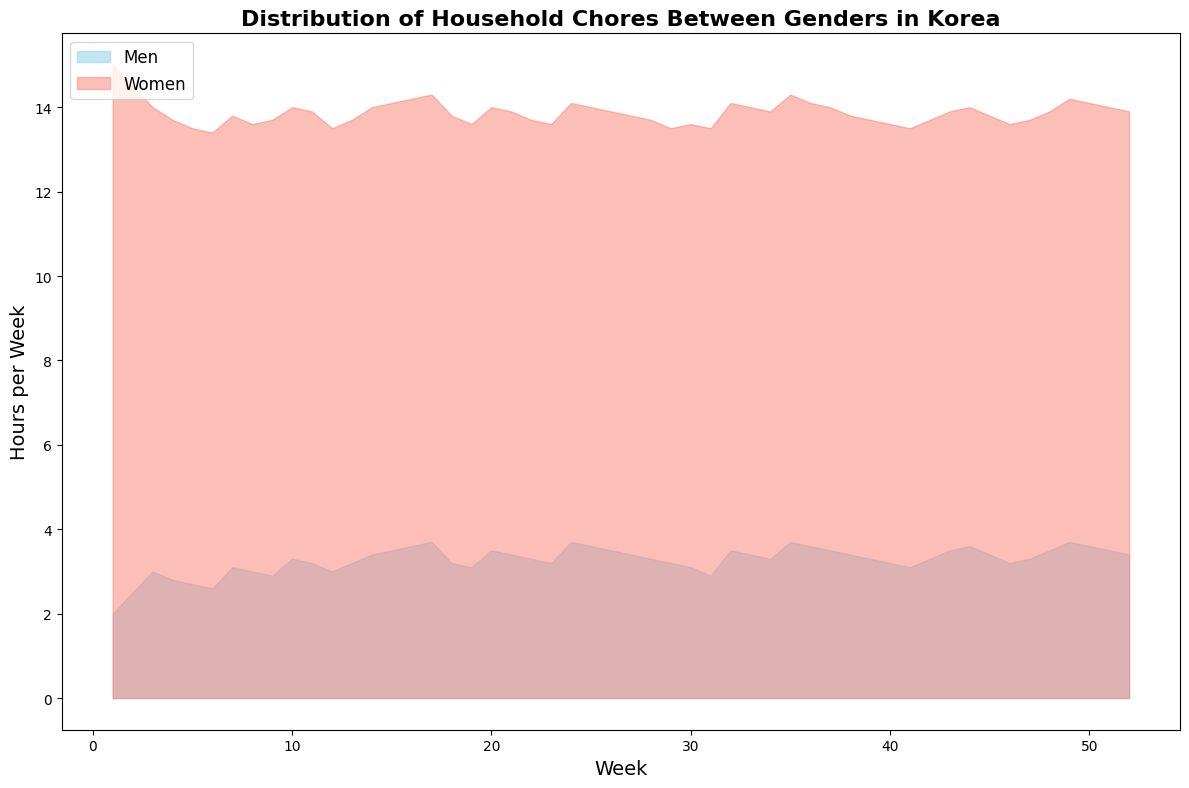What is the general trend of hours spent on household chores for men and women over the 52 weeks? By observing the area chart, we can see that the number of hours men spend on household chores slightly increases over the 52 weeks, starting from 2 hours per week and gradually rising to around 3.4-3.7 hours per week by the end. Meanwhile, women consistently spend significantly more hours on household chores, starting around 15 hours per week and gradually decreasing to approximately 13.6-14.3 hours per week.
Answer: Men: increasing, Women: slightly decreasing In which week did men spend the most hours on household chores? By checking the highest peak in the skyblue area on the graph, we see that men spent the most hours (3.7 hours) on household chores in Weeks 17, 24, and 49.
Answer: Week 17, 24, 49 How much more time do women spend on household chores compared to men on average in a week? To find the average difference, we need to calculate the average time spent by both genders over the 52 weeks. The average for men is around 3.221 hours/week, and for women, it is around 13.8 hours/week. The difference is 13.8 - 3.221 = 10.579 hours.
Answer: Approximately 10.6 hours In which weeks did men and women spend the equal amount of time on household chores? There is no week where men and women spend exactly the same amount of time.
Answer: None What is the biggest difference in hours between men and women in any week? To find the biggest difference, we check the week where the gap between the hours spent by men and women is largest. In Week 1, women spent 13 hours more than men (15 hours for women and 2 hours for men).
Answer: 13 hours What colors are used to represent men and women in the chart? The chart uses skyblue to represent men and salmon to represent women.
Answer: skyblue for men, salmon for women In Week 52, how much time do women spend on household chores, and how does it compare to men’s time? In Week 52, it’s visible from the chart that women spend around 13.9 hours on household chores, whereas men spend around 3.4 hours. The comparison shows women spend 10.5 more hours than men.
Answer: Women spend 13.9 hours, which is 10.5 hours more than men Which week shows the smallest difference in hours between men and women? The smallest difference will be where the two areas on the chart are closest. This occurs in Week 17 with men spending 3.7 hours and women 14.3 hours, leading to a 10.6 hours difference, the smallest in the range.
Answer: Week 17, with 10.6 hours difference What is the overall household chores trend for women over the year? Observing the pink area, it's noted that women's time on household chores decreases slightly but remains relatively steady, fluctuating between 13.5 and 15 hours over the 52 weeks.
Answer: Slightly decreasing but relatively stable 